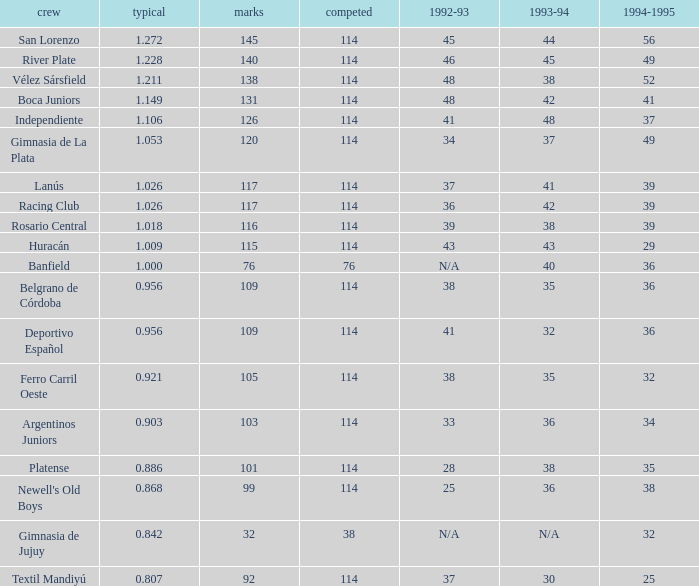Name the most played 114.0. 